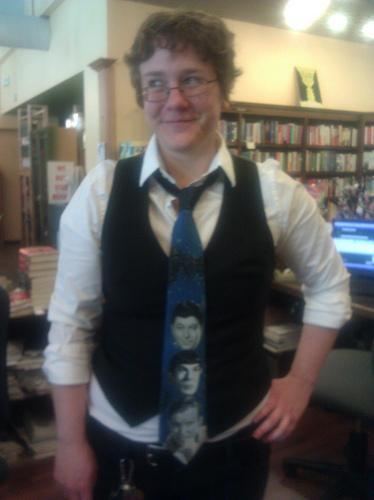How many people in the photo?
Give a very brief answer. 1. 